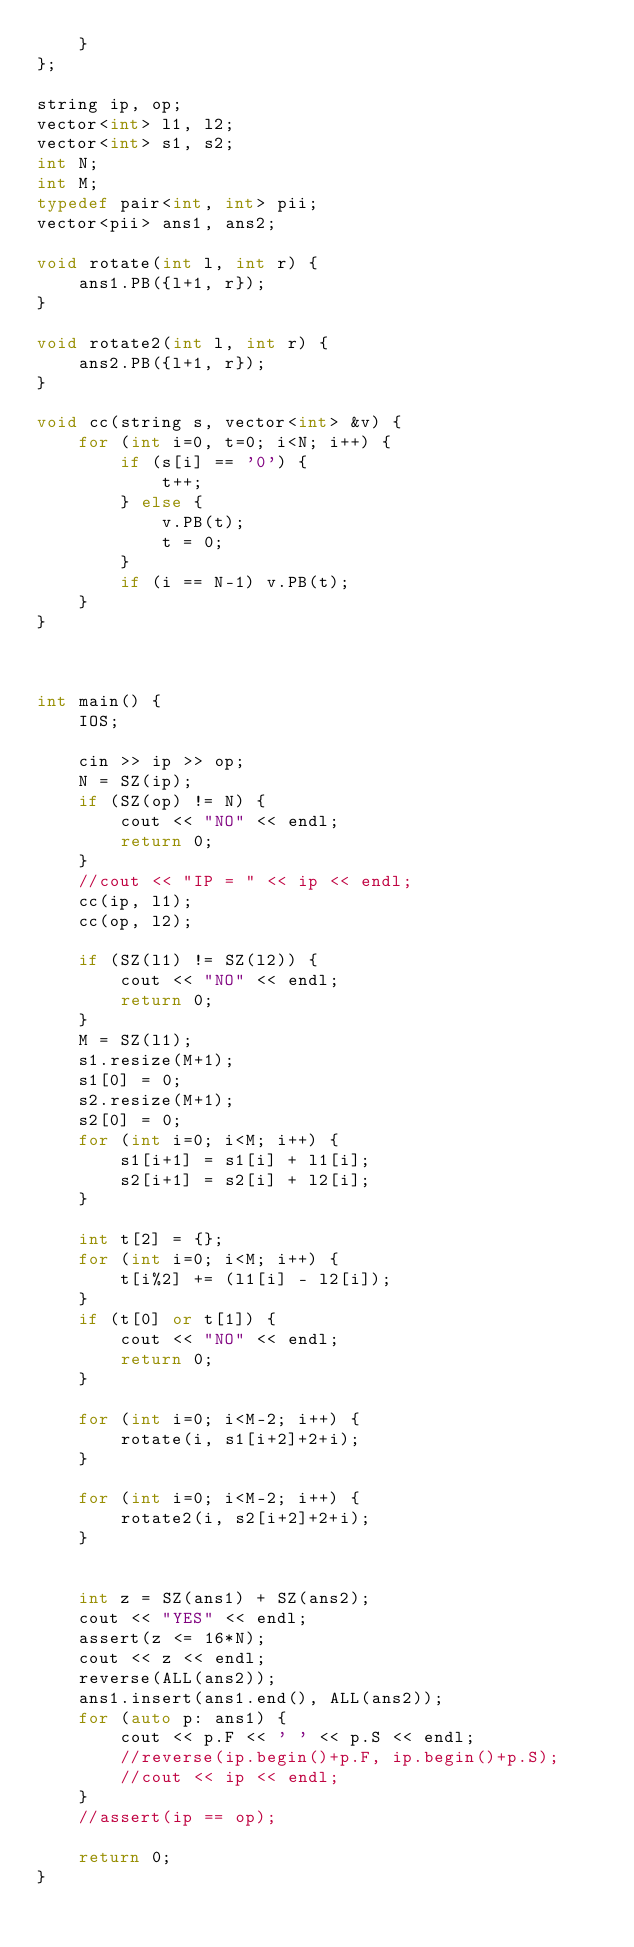Convert code to text. <code><loc_0><loc_0><loc_500><loc_500><_C++_>	}
};

string ip, op;
vector<int> l1, l2;
vector<int> s1, s2;
int N;
int M;
typedef pair<int, int> pii;
vector<pii> ans1, ans2;

void rotate(int l, int r) {
	ans1.PB({l+1, r});
}

void rotate2(int l, int r) {
	ans2.PB({l+1, r});
}

void cc(string s, vector<int> &v) {
	for (int i=0, t=0; i<N; i++) {
		if (s[i] == '0') {
			t++;
		} else {
			v.PB(t);
			t = 0;
		}
		if (i == N-1) v.PB(t);
	}
}



int main() {
	IOS;

	cin >> ip >> op;
	N = SZ(ip);
	if (SZ(op) != N) {
		cout << "NO" << endl;
		return 0;
	}
	//cout << "IP = " << ip << endl;
	cc(ip, l1);
	cc(op, l2);

	if (SZ(l1) != SZ(l2)) {
		cout << "NO" << endl;
		return 0;
	}
	M = SZ(l1);
	s1.resize(M+1);
	s1[0] = 0;
	s2.resize(M+1);
	s2[0] = 0;
	for (int i=0; i<M; i++) {
		s1[i+1] = s1[i] + l1[i];
		s2[i+1] = s2[i] + l2[i];
	}

	int t[2] = {};
	for (int i=0; i<M; i++) {
		t[i%2] += (l1[i] - l2[i]);
	}
	if (t[0] or t[1]) {
		cout << "NO" << endl;
		return 0;
	}

	for (int i=0; i<M-2; i++) {
		rotate(i, s1[i+2]+2+i);
	}

	for (int i=0; i<M-2; i++) {
		rotate2(i, s2[i+2]+2+i);
	}


	int z = SZ(ans1) + SZ(ans2);
	cout << "YES" << endl;
	assert(z <= 16*N);
	cout << z << endl;
	reverse(ALL(ans2));
	ans1.insert(ans1.end(), ALL(ans2));
	for (auto p: ans1) {
		cout << p.F << ' ' << p.S << endl;
		//reverse(ip.begin()+p.F, ip.begin()+p.S);
		//cout << ip << endl;
	}
	//assert(ip == op);

	return 0;
}


</code> 